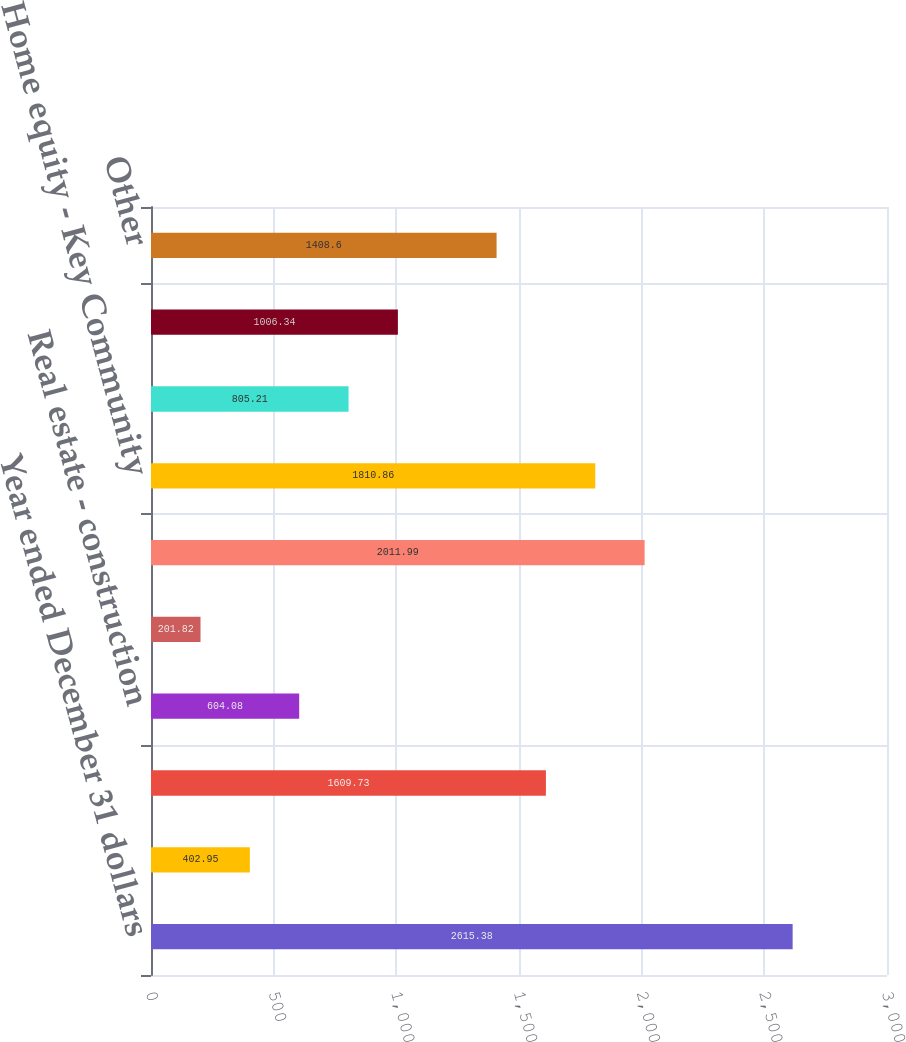<chart> <loc_0><loc_0><loc_500><loc_500><bar_chart><fcel>Year ended December 31 dollars<fcel>Commercial financial and<fcel>Real estate - commercial<fcel>Real estate - construction<fcel>Commercial lease financing<fcel>Total commercial loans<fcel>Home equity - Key Community<fcel>Home equity - Other<fcel>Marine<fcel>Other<nl><fcel>2615.38<fcel>402.95<fcel>1609.73<fcel>604.08<fcel>201.82<fcel>2011.99<fcel>1810.86<fcel>805.21<fcel>1006.34<fcel>1408.6<nl></chart> 